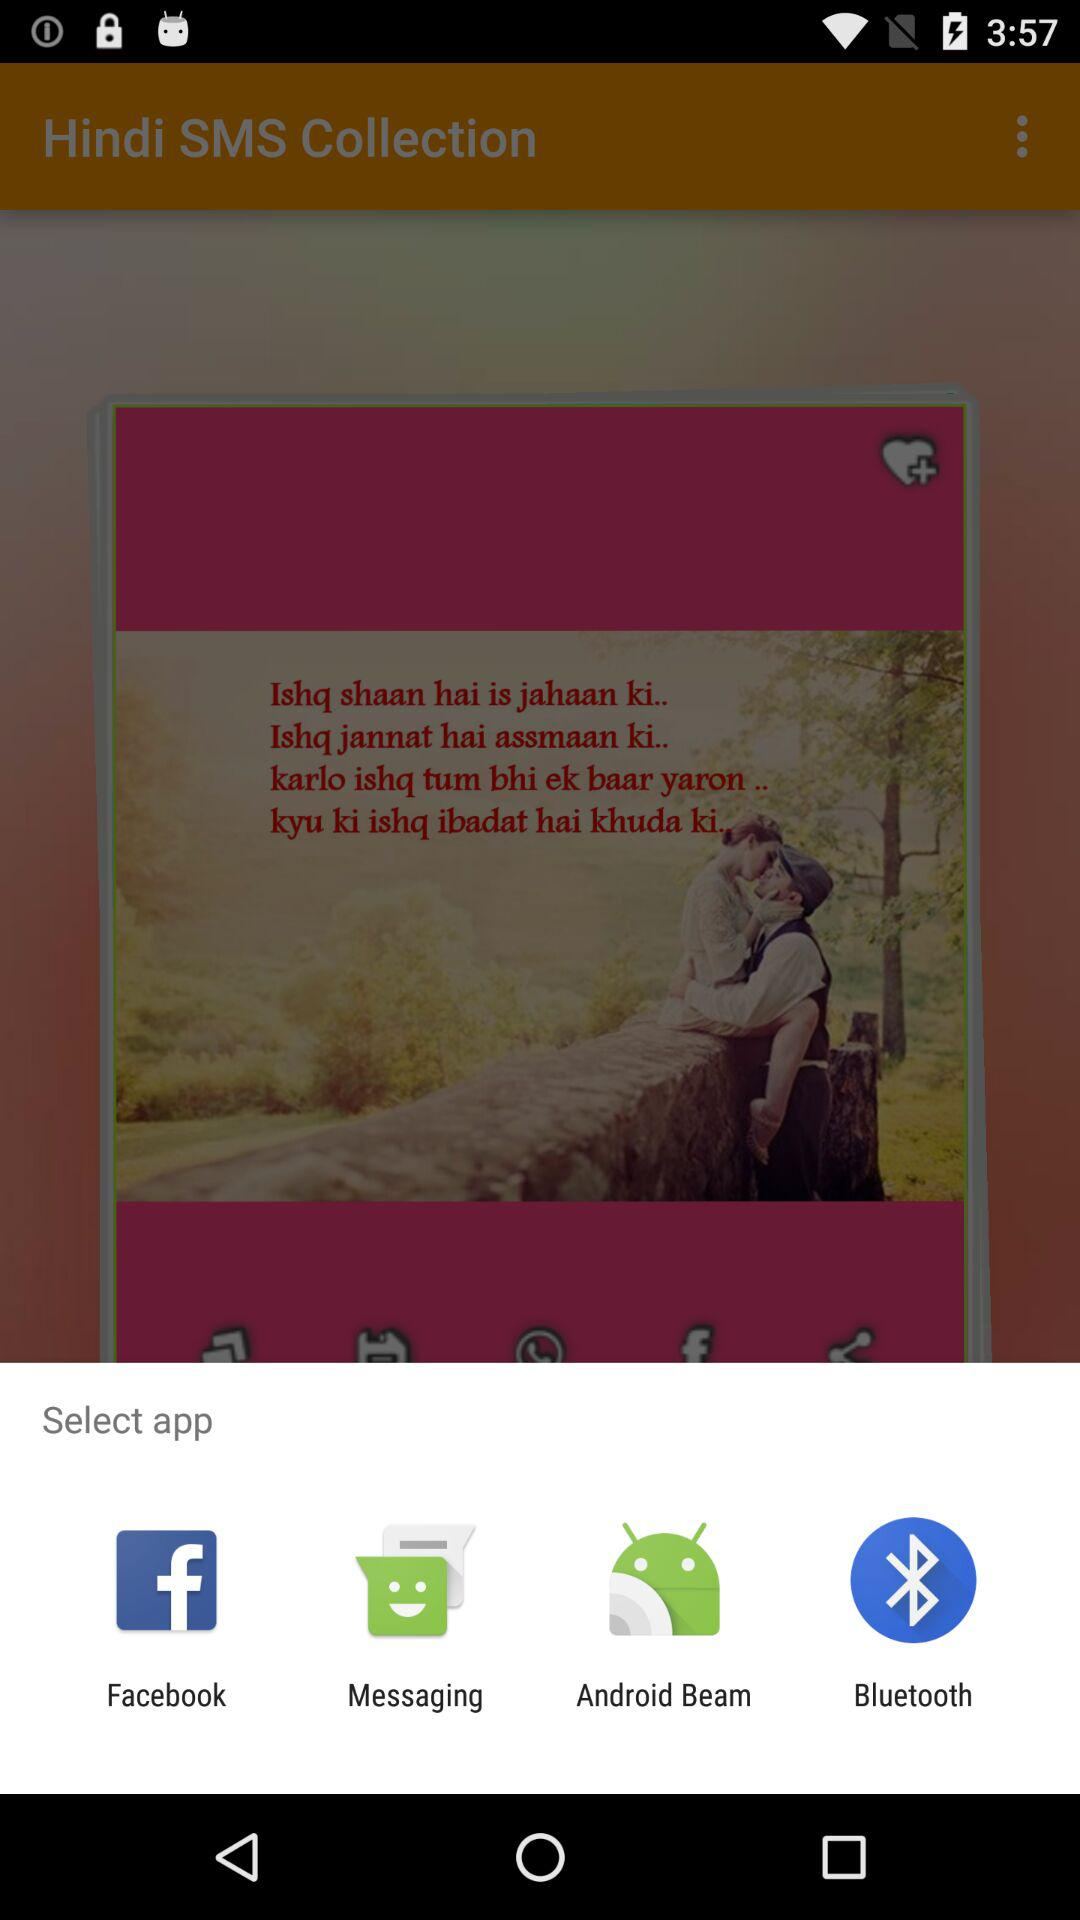Through what application can we open? We can open with "Facebook", "Messaging", "Android Beam" and "Bluetooth". 